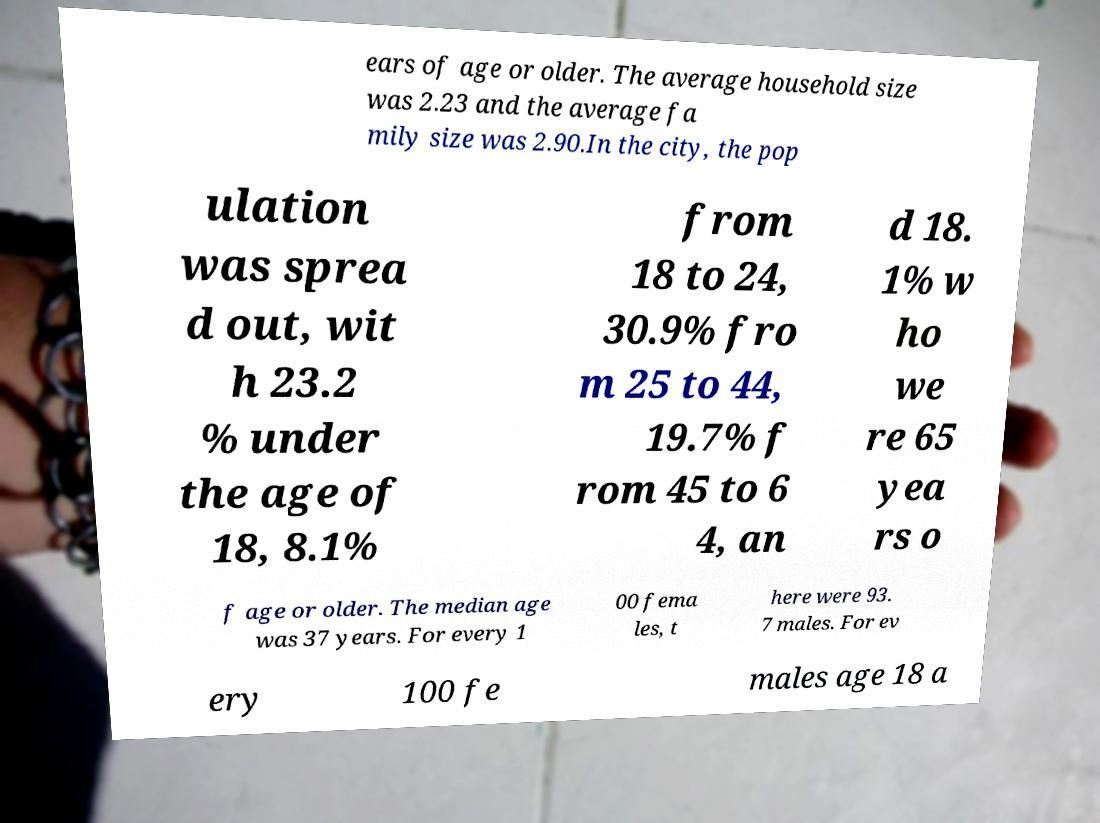Please identify and transcribe the text found in this image. ears of age or older. The average household size was 2.23 and the average fa mily size was 2.90.In the city, the pop ulation was sprea d out, wit h 23.2 % under the age of 18, 8.1% from 18 to 24, 30.9% fro m 25 to 44, 19.7% f rom 45 to 6 4, an d 18. 1% w ho we re 65 yea rs o f age or older. The median age was 37 years. For every 1 00 fema les, t here were 93. 7 males. For ev ery 100 fe males age 18 a 